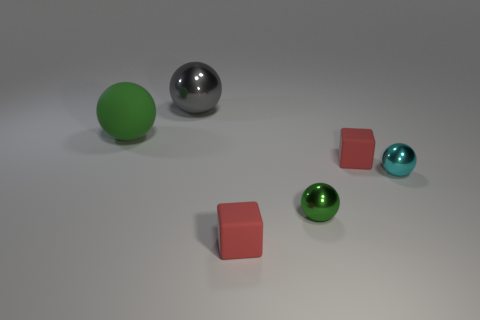Subtract all cyan metallic spheres. How many spheres are left? 3 Add 2 tiny brown rubber cubes. How many objects exist? 8 Subtract all gray cubes. How many green balls are left? 2 Subtract all green balls. How many balls are left? 2 Subtract all balls. How many objects are left? 2 Add 5 gray shiny objects. How many gray shiny objects exist? 6 Subtract 1 green spheres. How many objects are left? 5 Subtract 2 spheres. How many spheres are left? 2 Subtract all gray cubes. Subtract all blue cylinders. How many cubes are left? 2 Subtract all big gray spheres. Subtract all gray objects. How many objects are left? 4 